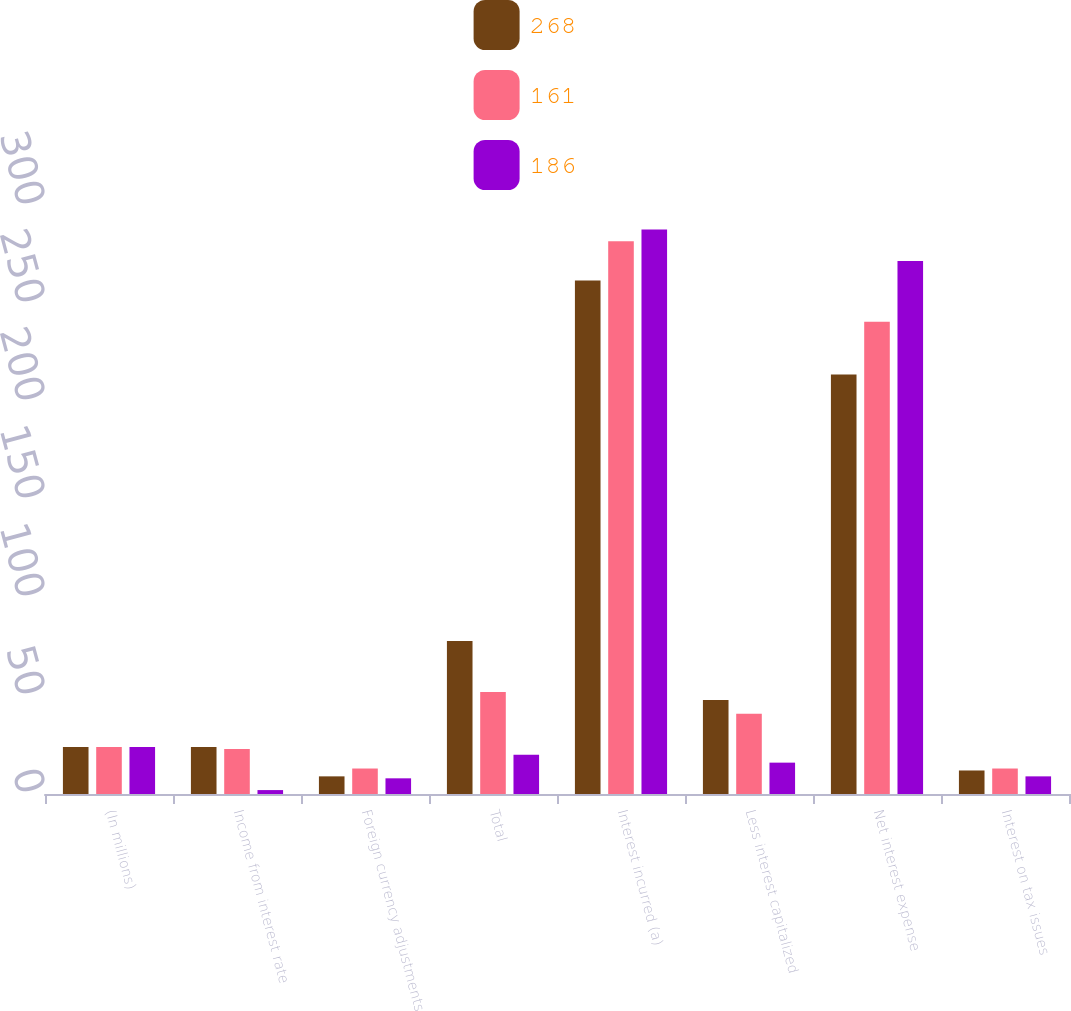Convert chart to OTSL. <chart><loc_0><loc_0><loc_500><loc_500><stacked_bar_chart><ecel><fcel>(In millions)<fcel>Income from interest rate<fcel>Foreign currency adjustments<fcel>Total<fcel>Interest incurred (a)<fcel>Less interest capitalized<fcel>Net interest expense<fcel>Interest on tax issues<nl><fcel>268<fcel>24<fcel>24<fcel>9<fcel>78<fcel>262<fcel>48<fcel>214<fcel>12<nl><fcel>161<fcel>24<fcel>23<fcel>13<fcel>52<fcel>282<fcel>41<fcel>241<fcel>13<nl><fcel>186<fcel>24<fcel>2<fcel>8<fcel>20<fcel>288<fcel>16<fcel>272<fcel>9<nl></chart> 